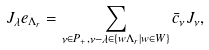Convert formula to latex. <formula><loc_0><loc_0><loc_500><loc_500>J _ { \lambda } e _ { \Lambda _ { r } } = \sum _ { \nu \in P _ { + } , \nu - \lambda \in \{ w \Lambda _ { r } | w \in W \} } \bar { c } _ { \nu } J _ { \nu } ,</formula> 